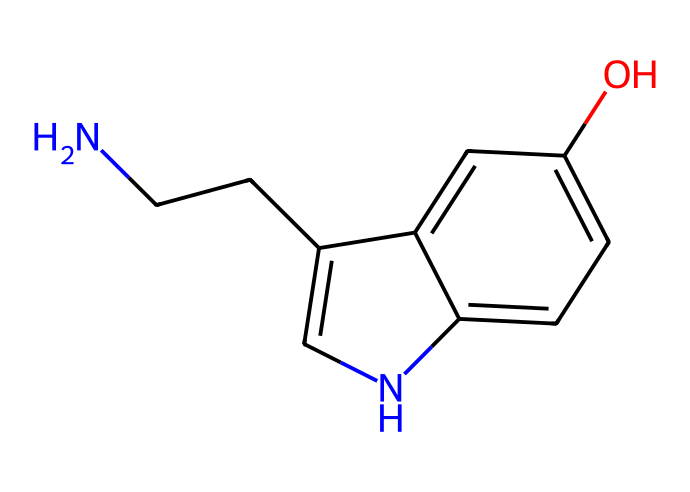What is the molecular formula of this chemical? To derive the molecular formula, we need to count the numbers of each type of atom in the structure represented by the SMILES. From the SMILES, we identify that there are 11 carbon atoms, 12 hydrogen atoms, 2 nitrogen atoms, and 1 oxygen atom. Therefore, the molecular formula is C11H12N2O.
Answer: C11H12N2O How many rings are present in this chemical structure? By analyzing the SMILES representation, we notice that there are numbers in the structure indicating ring closures (the '1' and '2' denote where the rings begin and end). There are two such indicators, showing that there is one ring structure formed in the molecule.
Answer: one What type of functional group is present in this chemical? Looking at the SMILES representation, we can identify the presence of the -OH group, which signifies that there is a hydroxyl functional group in this chemical. Since we are referring to serotonin's structure, it also includes an indole structure, but the specific functional group we are identifying here is the hydroxyl.
Answer: hydroxyl What is the primary role of this chemical in the human body? This chemical is primarily known to function as a neurotransmitter in the human body, involved in mood regulation, sleep, and appetite. Its significance in mental health is paramount, as it helps in controlling various emotional responses and mood.
Answer: neurotransmitter Does this chemical belong to the class of aldehydes? To determine if this molecule belongs to the class of aldehydes, we look for the presence of the carbonyl group (C=O) at the terminal end of a carbon chain. The structure derived from the SMILES does not show a carbonyl group at the end but rather presents a different arrangement with nitrogen-containing rings, hence it is categorized as an indole derivative.
Answer: no 